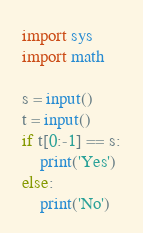<code> <loc_0><loc_0><loc_500><loc_500><_Python_>import sys
import math

s = input()
t = input()
if t[0:-1] == s:
    print('Yes')
else:
    print('No')
</code> 